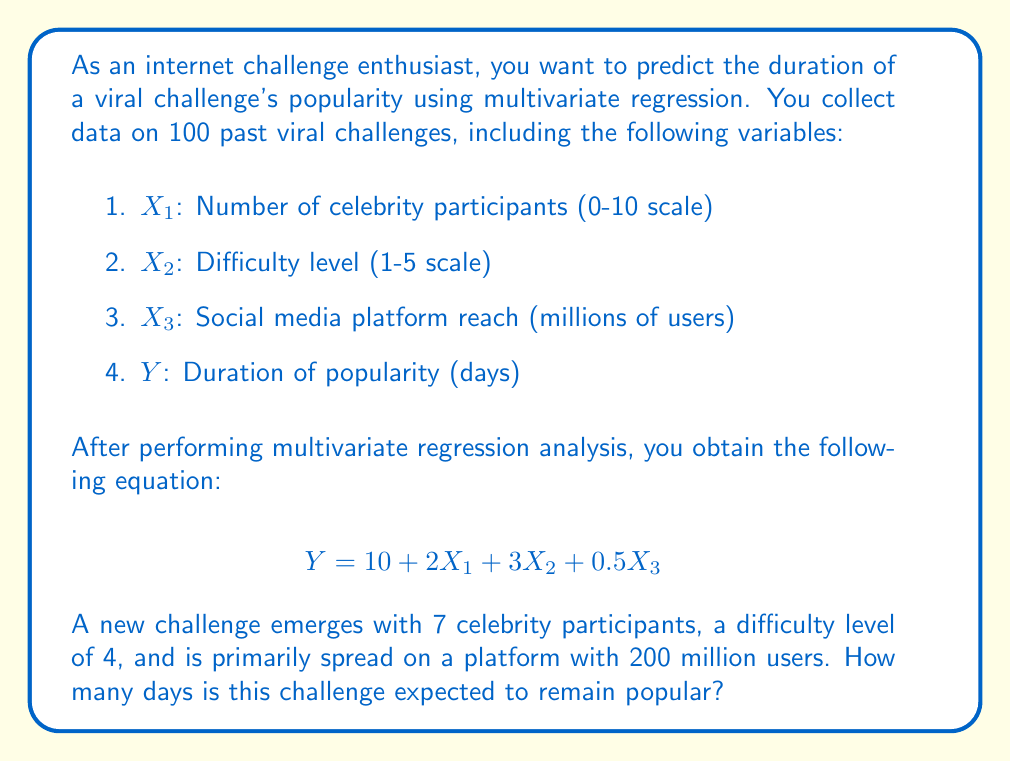Show me your answer to this math problem. To solve this problem, we need to use the multivariate regression equation provided and plug in the values for our new viral challenge. Let's break it down step by step:

1. Recall the regression equation:
   $$Y = 10 + 2X_1 + 3X_2 + 0.5X_3$$

2. We have the following information for our new challenge:
   - $X_1$ (Number of celebrity participants) = 7
   - $X_2$ (Difficulty level) = 4
   - $X_3$ (Social media platform reach) = 200 million users

3. Let's substitute these values into our equation:
   $$Y = 10 + 2(7) + 3(4) + 0.5(200)$$

4. Now, let's calculate each term:
   - $10$ (constant term)
   - $2(7) = 14$ (celebrity participants term)
   - $3(4) = 12$ (difficulty level term)
   - $0.5(200) = 100$ (social media reach term)

5. Sum up all the terms:
   $$Y = 10 + 14 + 12 + 100$$

6. Calculate the final result:
   $$Y = 136$$

Therefore, based on our multivariate regression model, we expect this new viral challenge to remain popular for 136 days.
Answer: 136 days 